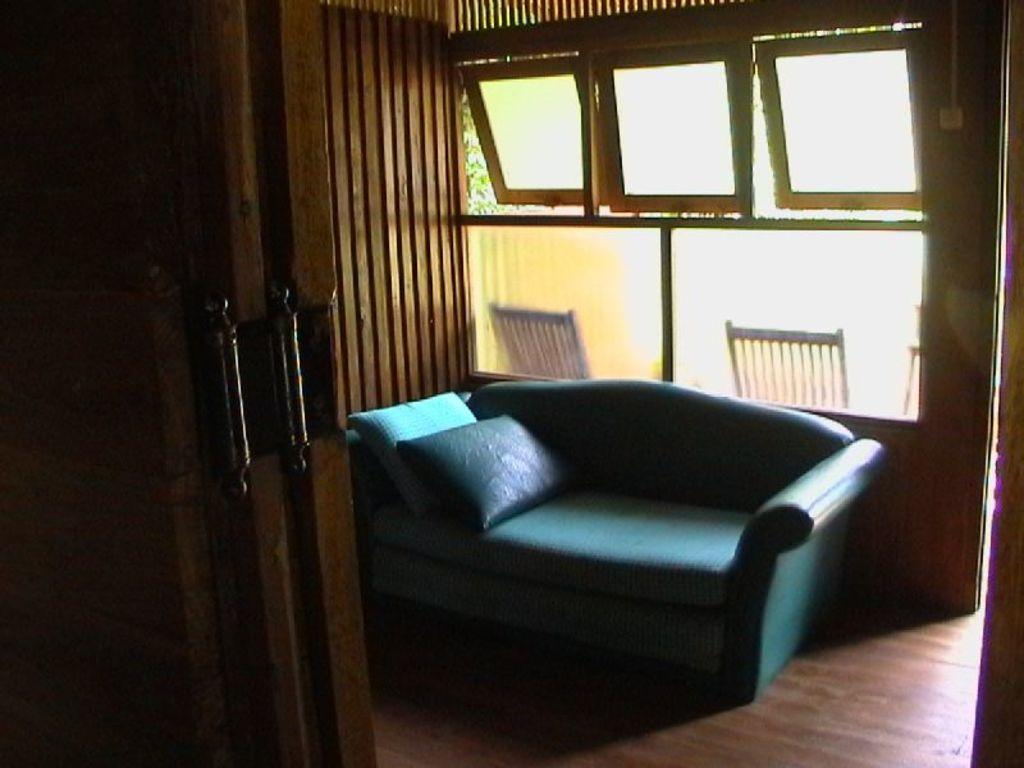What is the setting of the image? The image is inside a room. What type of furniture is present in the room? There is a blue couch in the room. Are there any additional features on the couch? Yes, the couch has pillows. What can be seen on the windows in the room? The windows have glass in the room. What is the price of the aunt's vein in the image? There is no mention of an aunt or a vein in the image, so it is not possible to determine the price of an aunt's vein. 